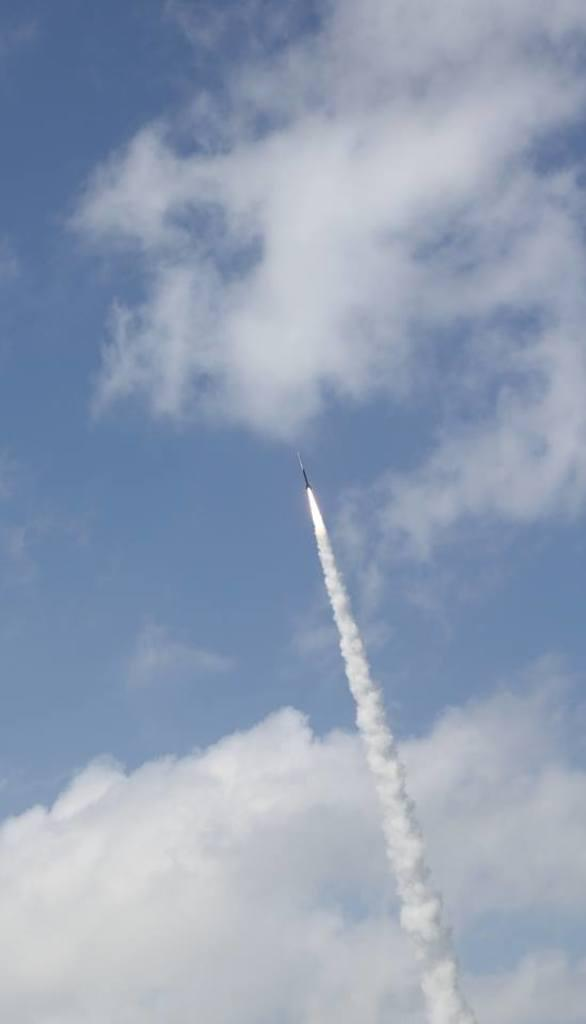Where was the picture taken? The picture was clicked outside. What is the main subject of the image? There is a rocket in the air in the image. What can be seen coming from the rocket? There is smoke visible in the image. What is visible in the background of the image? The sky is visible in the background of the image. What is the condition of the sky in the image? Clouds are present in the sky. What type of waste can be seen being collected in the image? There is no waste being collected in the image; it features a rocket in the air with smoke. What news headline is related to the image? There is no specific news headline related to the image; it simply shows a rocket in the air with smoke. 